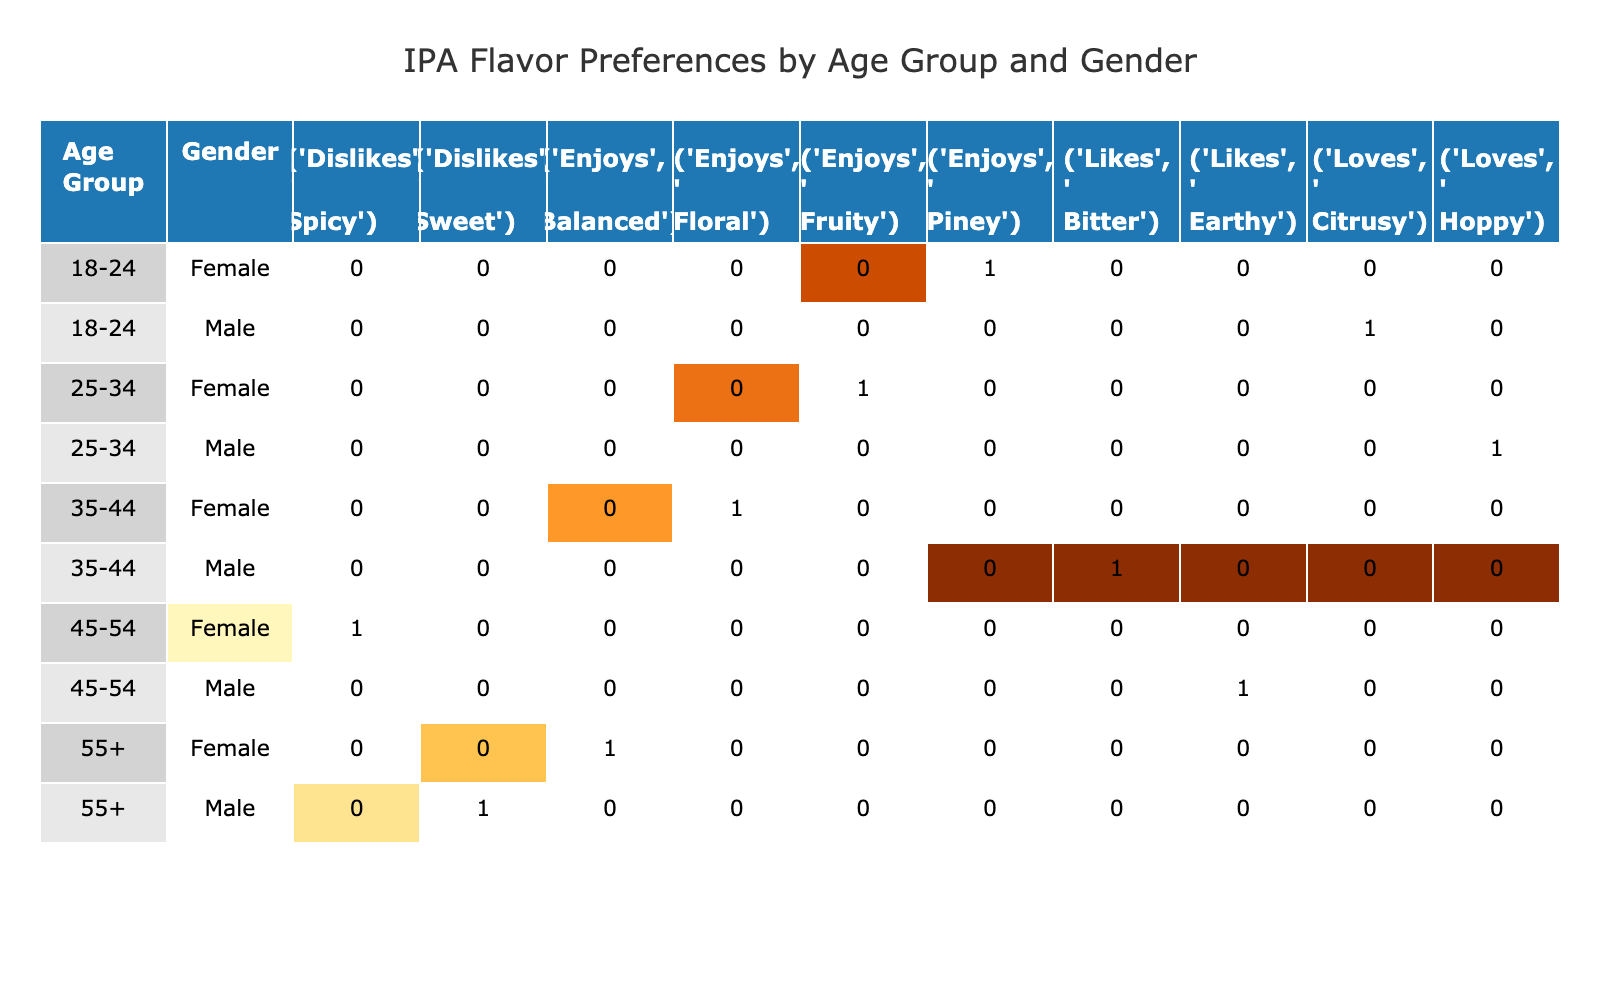What is the most common flavor profile preferred by males aged 25-34? Referring to the table, males in the 25-34 age group have a single preference for the flavor profile 'Hoppy' since there are no other entries for this demographic in the preference category.
Answer: Hoppy Which age group has a female who dislikes a flavor profile? By scanning the table, we find that the 45-54 age group has a female who 'Dislikes' the 'Spicy' flavor profile, making her the only female in the dataset with a dislike.
Answer: 45-54 How many flavor profiles do males aged 18-24 enjoy? Looking at the table, males aged 18-24 have one preference recorded which is 'Loves' for the 'Citrusy' profile. Therefore, there is a total of 1 flavor profile.
Answer: 1 Is there any gender in the 35-44 age group that prefers a sweet flavor profile? The table shows that for the 35-44 age group, the males 'Like' a 'Bitter' flavor profile and the females 'Enjoy' a 'Floral' flavor profile. There is no mention of anyone preferring a 'Sweet' flavor profile, hence the answer is no.
Answer: No What is the total number of female entries in the table? Counting the entries in the table, we find there are 5 instances of females recorded across different age groups and flavor preferences.
Answer: 5 Which demographic group shows a preference for the 'Balanced' flavor profile? Checking the table, we see that the only demographic that shows a preference for 'Balanced' is females aged 55 and above.
Answer: Females aged 55+ How many distinct flavor profiles do males enjoy overall? The table reveals the males' preferences for the following distinct flavor profiles: 'Citrusy', 'Hoppy', 'Bitter', and 'Earthy'. This gives a total of 4 distinct flavor profiles enjoyed by males.
Answer: 4 Do any individuals aged 45-54 show a preference for 'Hoppy'? The table shows that in the 45-54 age group, males prefer 'Earthy' and the females 'Dislike' 'Spicy'. Therefore, none of them prefer 'Hoppy'.
Answer: No What flavor profile is liked by the oldest male demographic? According to the table, the oldest male demographic (55+) shows a preference for 'Sweet', which is marked as a dislike by the other males. This is the only entry for this group.
Answer: Sweet What is the difference in flavor profile preference between males and females in the age group 35-44? In the 35-44 age group, males 'Like' the 'Bitter' flavor as a preference while females 'Enjoy' the 'Floral' flavor. The difference is that they have distinct preferences for their flavor profiles.
Answer: Bitter and Floral 